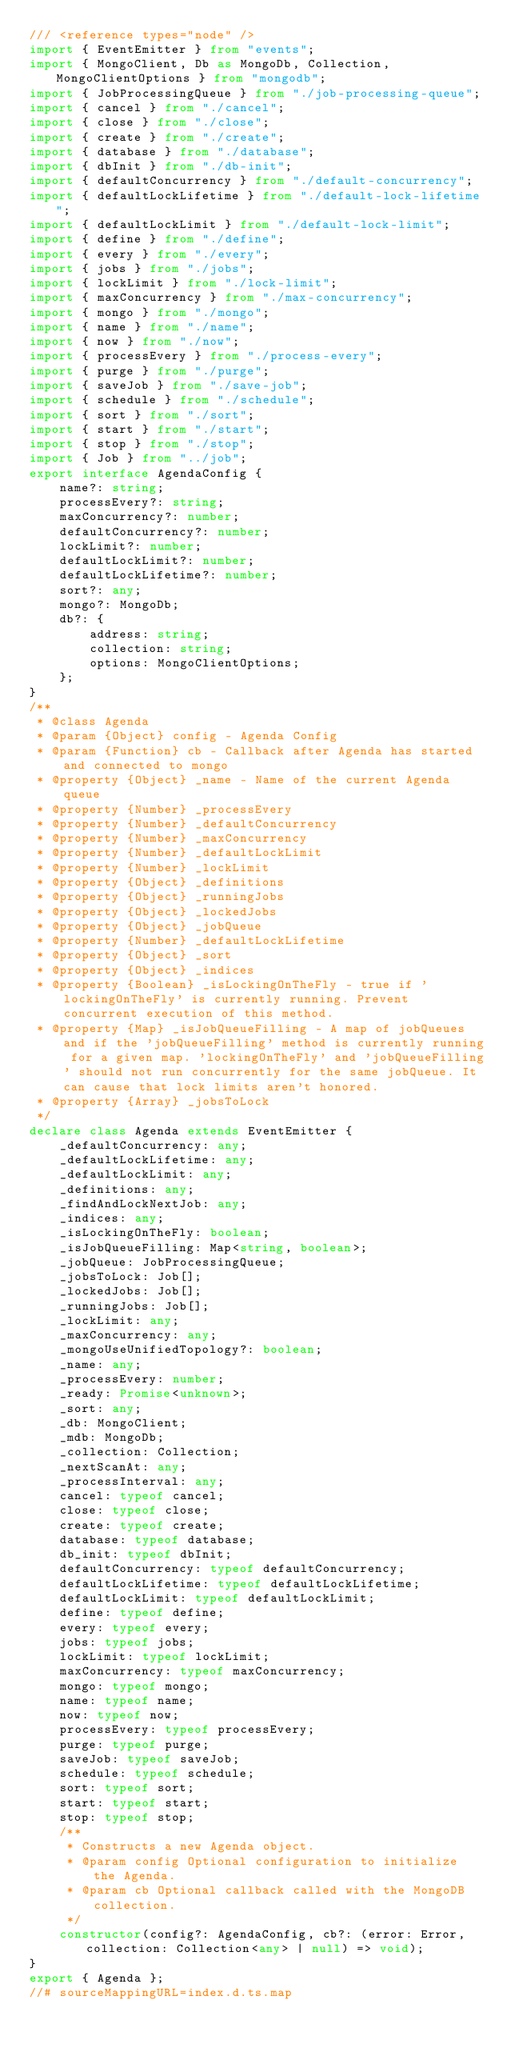<code> <loc_0><loc_0><loc_500><loc_500><_TypeScript_>/// <reference types="node" />
import { EventEmitter } from "events";
import { MongoClient, Db as MongoDb, Collection, MongoClientOptions } from "mongodb";
import { JobProcessingQueue } from "./job-processing-queue";
import { cancel } from "./cancel";
import { close } from "./close";
import { create } from "./create";
import { database } from "./database";
import { dbInit } from "./db-init";
import { defaultConcurrency } from "./default-concurrency";
import { defaultLockLifetime } from "./default-lock-lifetime";
import { defaultLockLimit } from "./default-lock-limit";
import { define } from "./define";
import { every } from "./every";
import { jobs } from "./jobs";
import { lockLimit } from "./lock-limit";
import { maxConcurrency } from "./max-concurrency";
import { mongo } from "./mongo";
import { name } from "./name";
import { now } from "./now";
import { processEvery } from "./process-every";
import { purge } from "./purge";
import { saveJob } from "./save-job";
import { schedule } from "./schedule";
import { sort } from "./sort";
import { start } from "./start";
import { stop } from "./stop";
import { Job } from "../job";
export interface AgendaConfig {
    name?: string;
    processEvery?: string;
    maxConcurrency?: number;
    defaultConcurrency?: number;
    lockLimit?: number;
    defaultLockLimit?: number;
    defaultLockLifetime?: number;
    sort?: any;
    mongo?: MongoDb;
    db?: {
        address: string;
        collection: string;
        options: MongoClientOptions;
    };
}
/**
 * @class Agenda
 * @param {Object} config - Agenda Config
 * @param {Function} cb - Callback after Agenda has started and connected to mongo
 * @property {Object} _name - Name of the current Agenda queue
 * @property {Number} _processEvery
 * @property {Number} _defaultConcurrency
 * @property {Number} _maxConcurrency
 * @property {Number} _defaultLockLimit
 * @property {Number} _lockLimit
 * @property {Object} _definitions
 * @property {Object} _runningJobs
 * @property {Object} _lockedJobs
 * @property {Object} _jobQueue
 * @property {Number} _defaultLockLifetime
 * @property {Object} _sort
 * @property {Object} _indices
 * @property {Boolean} _isLockingOnTheFly - true if 'lockingOnTheFly' is currently running. Prevent concurrent execution of this method.
 * @property {Map} _isJobQueueFilling - A map of jobQueues and if the 'jobQueueFilling' method is currently running for a given map. 'lockingOnTheFly' and 'jobQueueFilling' should not run concurrently for the same jobQueue. It can cause that lock limits aren't honored.
 * @property {Array} _jobsToLock
 */
declare class Agenda extends EventEmitter {
    _defaultConcurrency: any;
    _defaultLockLifetime: any;
    _defaultLockLimit: any;
    _definitions: any;
    _findAndLockNextJob: any;
    _indices: any;
    _isLockingOnTheFly: boolean;
    _isJobQueueFilling: Map<string, boolean>;
    _jobQueue: JobProcessingQueue;
    _jobsToLock: Job[];
    _lockedJobs: Job[];
    _runningJobs: Job[];
    _lockLimit: any;
    _maxConcurrency: any;
    _mongoUseUnifiedTopology?: boolean;
    _name: any;
    _processEvery: number;
    _ready: Promise<unknown>;
    _sort: any;
    _db: MongoClient;
    _mdb: MongoDb;
    _collection: Collection;
    _nextScanAt: any;
    _processInterval: any;
    cancel: typeof cancel;
    close: typeof close;
    create: typeof create;
    database: typeof database;
    db_init: typeof dbInit;
    defaultConcurrency: typeof defaultConcurrency;
    defaultLockLifetime: typeof defaultLockLifetime;
    defaultLockLimit: typeof defaultLockLimit;
    define: typeof define;
    every: typeof every;
    jobs: typeof jobs;
    lockLimit: typeof lockLimit;
    maxConcurrency: typeof maxConcurrency;
    mongo: typeof mongo;
    name: typeof name;
    now: typeof now;
    processEvery: typeof processEvery;
    purge: typeof purge;
    saveJob: typeof saveJob;
    schedule: typeof schedule;
    sort: typeof sort;
    start: typeof start;
    stop: typeof stop;
    /**
     * Constructs a new Agenda object.
     * @param config Optional configuration to initialize the Agenda.
     * @param cb Optional callback called with the MongoDB collection.
     */
    constructor(config?: AgendaConfig, cb?: (error: Error, collection: Collection<any> | null) => void);
}
export { Agenda };
//# sourceMappingURL=index.d.ts.map</code> 